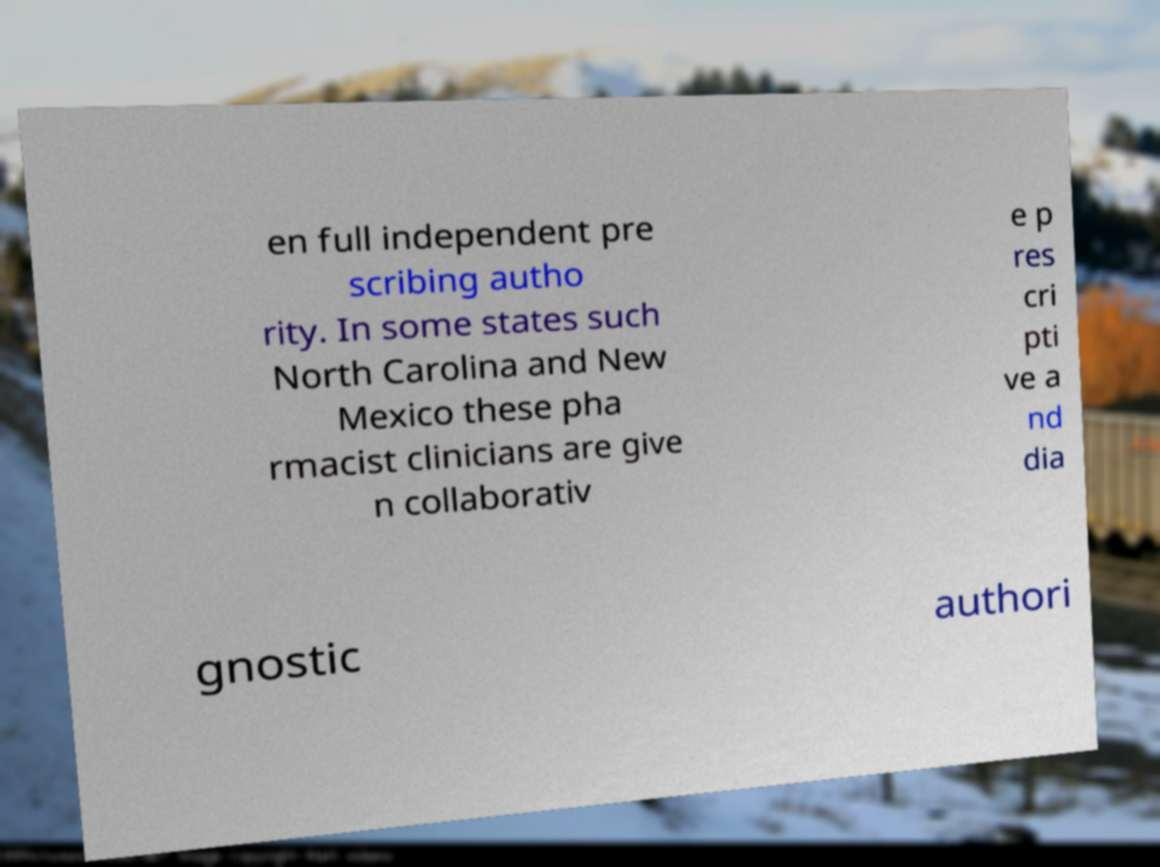Could you assist in decoding the text presented in this image and type it out clearly? en full independent pre scribing autho rity. In some states such North Carolina and New Mexico these pha rmacist clinicians are give n collaborativ e p res cri pti ve a nd dia gnostic authori 